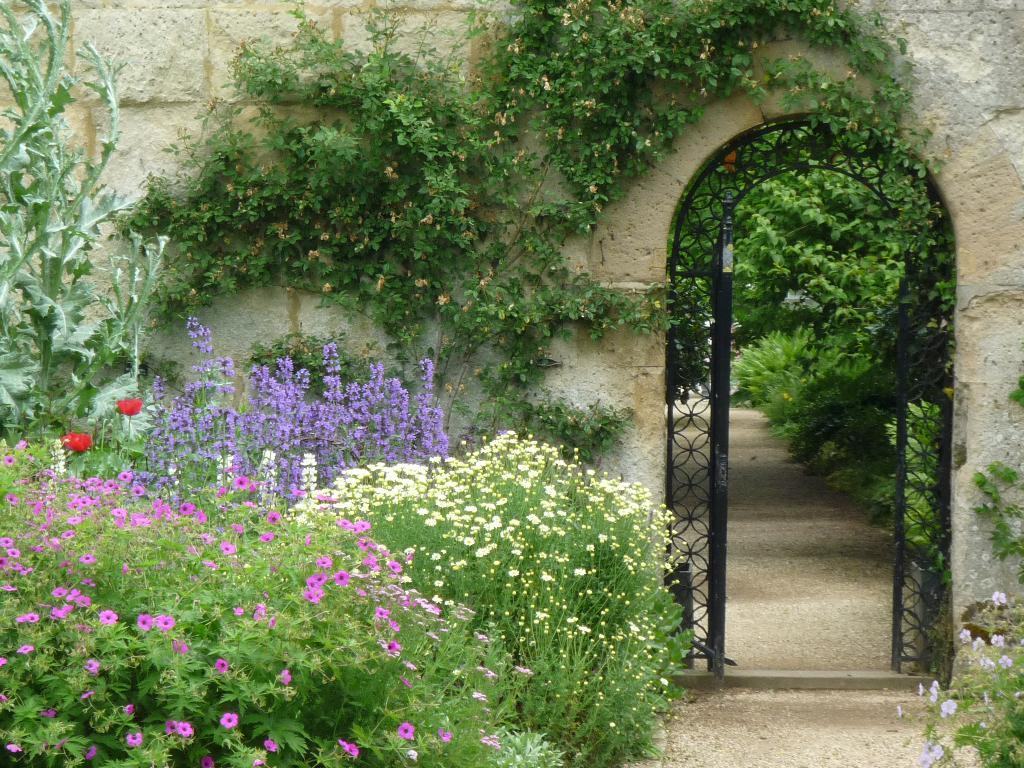What type of plants can be seen in the image? There are plants with flowers in the image. What is the creeper plant doing in the image? The creeper plant is growing on the wall in the image. What architectural feature is present in the image? There is an arch in the image. What type of vegetation is visible in the image besides the plants with flowers? There are trees in the image. What type of cable can be seen hanging from the arch in the image? A: There is no cable visible in the image; it only features plants, a creeper plant, an arch, and trees. 